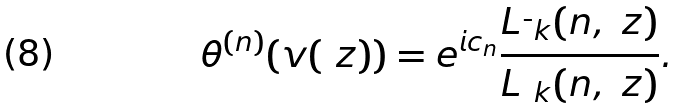Convert formula to latex. <formula><loc_0><loc_0><loc_500><loc_500>\theta ^ { ( n ) } ( v ( \ z ) ) = e ^ { i c _ { n } } \frac { L _ { \bar { \ } k } ( n , \ z ) } { L _ { \ k } ( n , \ z ) } .</formula> 